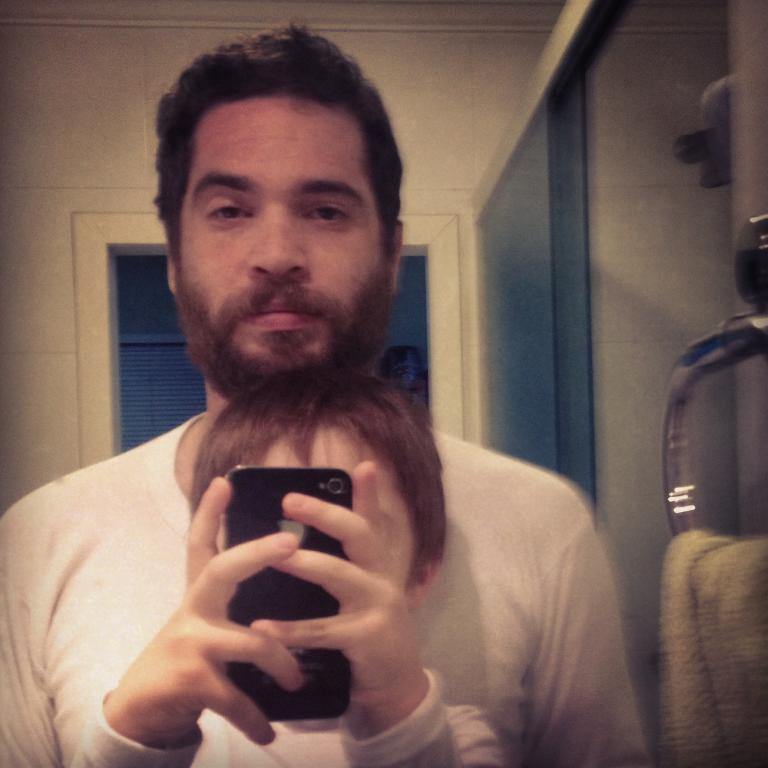Can you describe this image briefly? In this photo a man is standing behind this boy who is taking picture from this Iphone. 